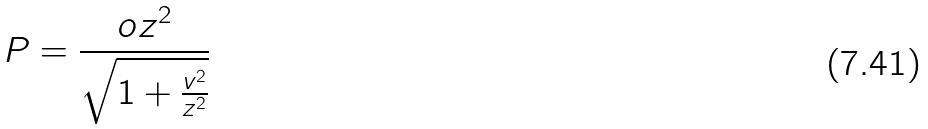Convert formula to latex. <formula><loc_0><loc_0><loc_500><loc_500>P = \frac { o z ^ { 2 } } { \sqrt { 1 + \frac { v ^ { 2 } } { z ^ { 2 } } } }</formula> 